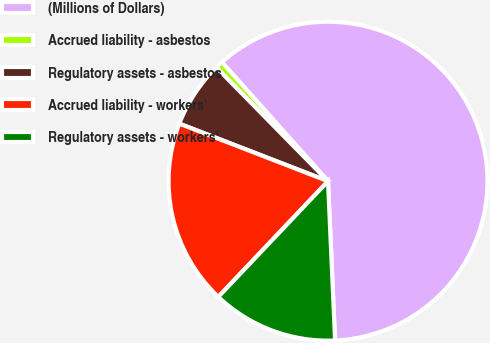Convert chart. <chart><loc_0><loc_0><loc_500><loc_500><pie_chart><fcel>(Millions of Dollars)<fcel>Accrued liability - asbestos<fcel>Regulatory assets - asbestos<fcel>Accrued liability - workers'<fcel>Regulatory assets - workers'<nl><fcel>60.89%<fcel>0.76%<fcel>6.77%<fcel>18.8%<fcel>12.78%<nl></chart> 